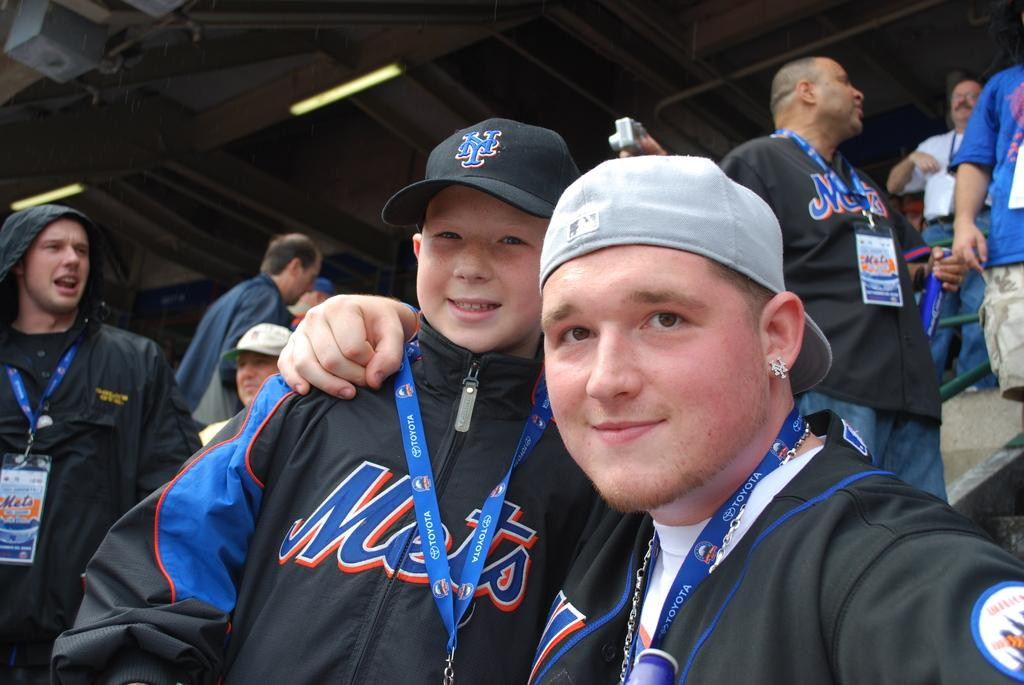<image>
Render a clear and concise summary of the photo. the boy with ear piercing is next to the boy wearing a Mets jacket 